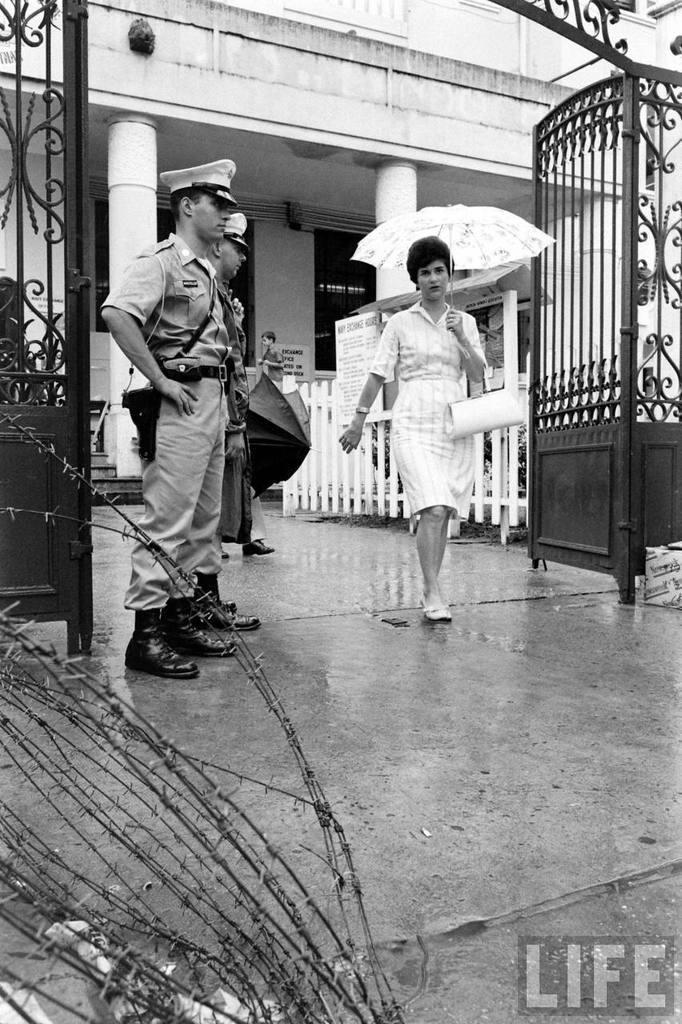In one or two sentences, can you explain what this image depicts? In this picture we can see two men wore caps and standing and in front of them we can see a woman holding an umbrella with her hand and walking on the ground, gate, fence, box, posters and some objects and in the background we can see pillars, building and some people. 